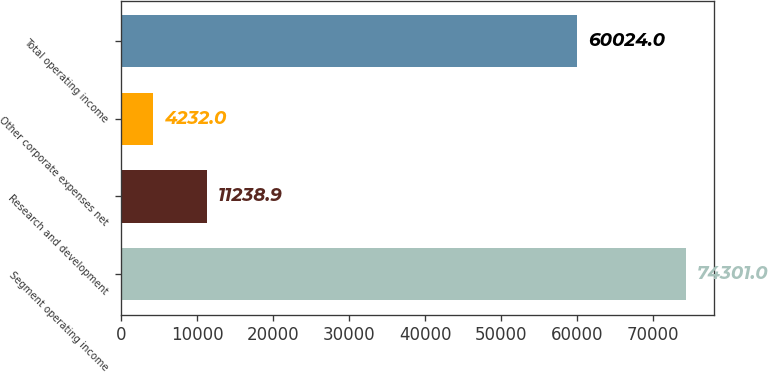<chart> <loc_0><loc_0><loc_500><loc_500><bar_chart><fcel>Segment operating income<fcel>Research and development<fcel>Other corporate expenses net<fcel>Total operating income<nl><fcel>74301<fcel>11238.9<fcel>4232<fcel>60024<nl></chart> 